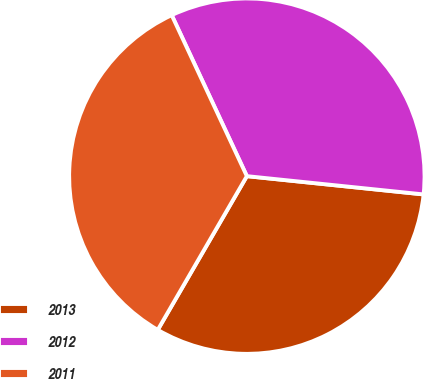Convert chart. <chart><loc_0><loc_0><loc_500><loc_500><pie_chart><fcel>2013<fcel>2012<fcel>2011<nl><fcel>31.72%<fcel>33.59%<fcel>34.69%<nl></chart> 